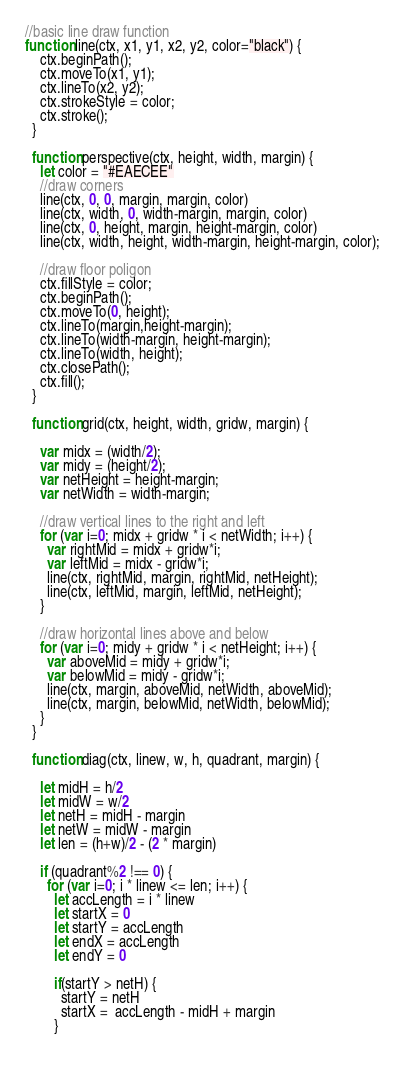Convert code to text. <code><loc_0><loc_0><loc_500><loc_500><_JavaScript_>//basic line draw function
function line(ctx, x1, y1, x2, y2, color="black") {
    ctx.beginPath();
    ctx.moveTo(x1, y1);
    ctx.lineTo(x2, y2);
    ctx.strokeStyle = color;
    ctx.stroke();
  }
  
  function perspective(ctx, height, width, margin) {
    let color = "#EAECEE"
    //draw corners
    line(ctx, 0, 0, margin, margin, color)
    line(ctx, width, 0, width-margin, margin, color)
    line(ctx, 0, height, margin, height-margin, color)
    line(ctx, width, height, width-margin, height-margin, color);
  
    //draw floor poligon
    ctx.fillStyle = color;
    ctx.beginPath();
    ctx.moveTo(0, height);
    ctx.lineTo(margin,height-margin);
    ctx.lineTo(width-margin, height-margin);
    ctx.lineTo(width, height);
    ctx.closePath();
    ctx.fill();
  }
  
  function grid(ctx, height, width, gridw, margin) {
  
    var midx = (width/2);
    var midy = (height/2);
    var netHeight = height-margin;
    var netWidth = width-margin;
  
    //draw vertical lines to the right and left
    for (var i=0; midx + gridw * i < netWidth; i++) {
      var rightMid = midx + gridw*i;
      var leftMid = midx - gridw*i;
      line(ctx, rightMid, margin, rightMid, netHeight);
      line(ctx, leftMid, margin, leftMid, netHeight);
    }
  
    //draw horizontal lines above and below
    for (var i=0; midy + gridw * i < netHeight; i++) {
      var aboveMid = midy + gridw*i;
      var belowMid = midy - gridw*i;
      line(ctx, margin, aboveMid, netWidth, aboveMid);
      line(ctx, margin, belowMid, netWidth, belowMid);
    }
  }
  
  function diag(ctx, linew, w, h, quadrant, margin) {
    
    let midH = h/2
    let midW = w/2
    let netH = midH - margin
    let netW = midW - margin
    let len = (h+w)/2 - (2 * margin)
  
    if (quadrant%2 !== 0) {
      for (var i=0; i * linew <= len; i++) {
        let accLength = i * linew
        let startX = 0
        let startY = accLength
        let endX = accLength
        let endY = 0
  
        if(startY > netH) {
          startY = netH
          startX =  accLength - midH + margin
        }
  </code> 